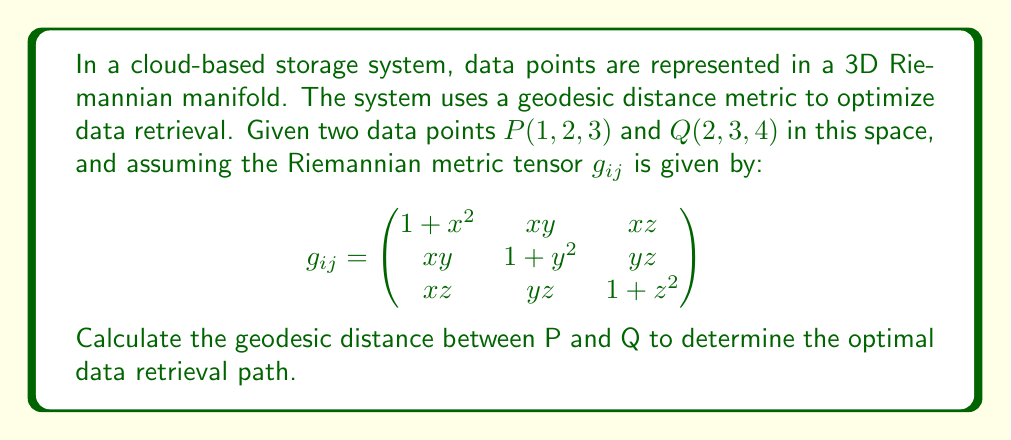What is the answer to this math problem? To solve this problem, we'll follow these steps:

1) First, we need to understand that the geodesic distance in a Riemannian manifold is given by the integral:

   $$d(P,Q) = \int_{0}^{1} \sqrt{g_{ij}\frac{dx^i}{dt}\frac{dx^j}{dt}} dt$$

   where $x^i(t)$ represents the path from P to Q parameterized by t.

2) For simplicity, we'll assume a straight line path between P and Q:
   
   $x(t) = 1 + t$
   $y(t) = 2 + t$
   $z(t) = 3 + t$

3) Calculate the derivatives:
   
   $\frac{dx}{dt} = \frac{dy}{dt} = \frac{dz}{dt} = 1$

4) Now, we need to evaluate $g_{ij}\frac{dx^i}{dt}\frac{dx^j}{dt}$:

   $$\begin{aligned}
   &(1+(1+t)^2) \cdot 1^2 + ((1+t)(2+t)) \cdot 1 \cdot 1 + ((1+t)(3+t)) \cdot 1 \cdot 1 \\
   &+ ((1+t)(2+t)) \cdot 1 \cdot 1 + (1+(2+t)^2) \cdot 1^2 + ((2+t)(3+t)) \cdot 1 \cdot 1 \\
   &+ ((1+t)(3+t)) \cdot 1 \cdot 1 + ((2+t)(3+t)) \cdot 1 \cdot 1 + (1+(3+t)^2) \cdot 1^2
   \end{aligned}$$

5) Simplify:

   $$2 + (1+t)^2 + (2+t)^2 + (3+t)^2 + 2(1+t)(2+t) + 2(1+t)(3+t) + 2(2+t)(3+t)$$

6) This gives us the integrand. The geodesic distance is the integral of the square root of this from 0 to 1:

   $$d(P,Q) = \int_{0}^{1} \sqrt{2 + (1+t)^2 + (2+t)^2 + (3+t)^2 + 2(1+t)(2+t) + 2(1+t)(3+t) + 2(2+t)(3+t)} dt$$

7) This integral doesn't have a simple closed form solution. It would typically be evaluated numerically in a real-world application.
Answer: $\int_{0}^{1} \sqrt{2 + (1+t)^2 + (2+t)^2 + (3+t)^2 + 2(1+t)(2+t) + 2(1+t)(3+t) + 2(2+t)(3+t)} dt$ 